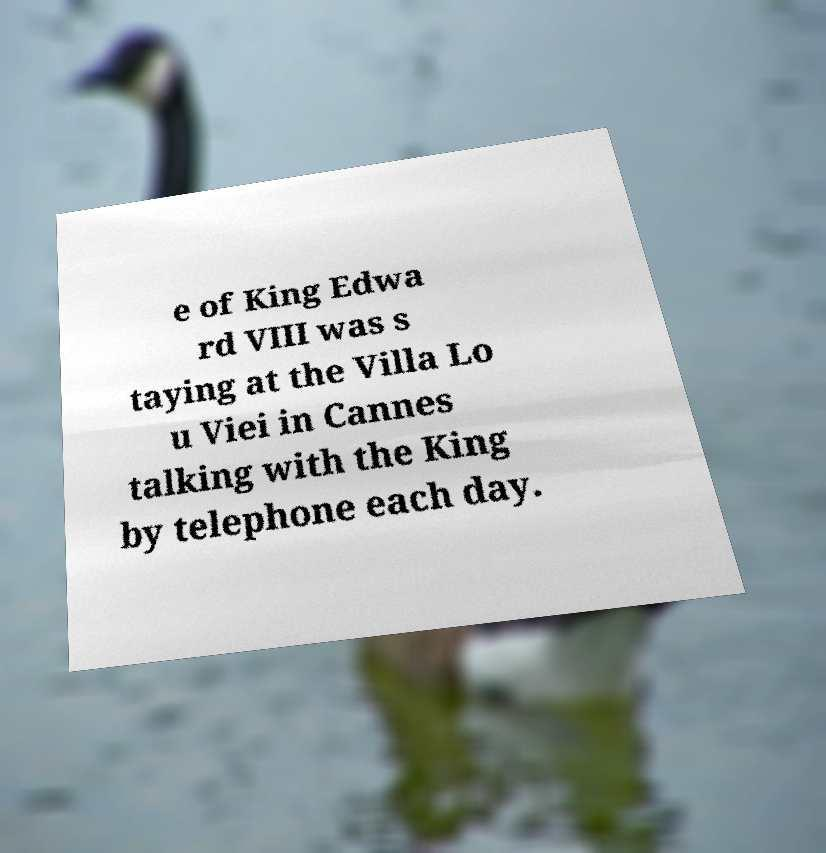There's text embedded in this image that I need extracted. Can you transcribe it verbatim? e of King Edwa rd VIII was s taying at the Villa Lo u Viei in Cannes talking with the King by telephone each day. 